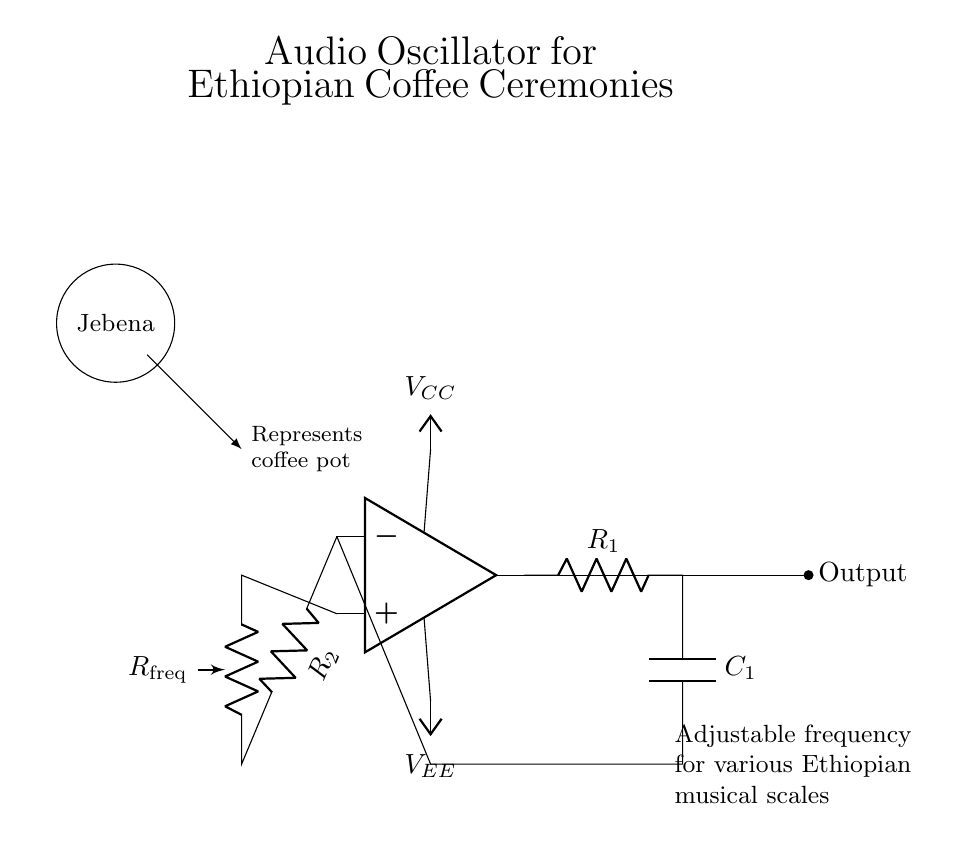What components are used in this oscillator? The components include an operational amplifier, resistors R1, R2, and Rfreq, and a capacitor C1. The operational amplifier is the main active component that provides the required gain for oscillation. The resistors and capacitor create a feedback network that determines the frequency of oscillation.
Answer: operational amplifier, resistors, capacitor What is the role of the capacitor in this circuit? The capacitor C1 is part of the feedback network and plays a critical role in determining the frequency of the generated audio signals. It works together with resistor R1 to set the timing characteristics of the oscillator, influencing how quickly the circuit can charge and discharge.
Answer: frequency determination What is the input voltage of the operational amplifier? The input voltage is denoted as Vcc for the positive and Vee for the negative supply. The circuit specifies power connections to the op-amp, indicating it operates with a dual power supply.
Answer: Vcc and Vee How does the frequency change in this circuit? The frequency can be adjusted by changing the resistance of Rfreq or the values of R1 and C1. An increase in the resistance or capacitance will lower the frequency, while a decrease will raise it. The circuit is designed to allow flexibility in tuning to accommodate different musical scales in Ethiopian music.
Answer: by adjusting Rfreq What does the symbol 'Jebena' represent in the circuit? The 'Jebena' symbol depicted above the circuit serves as a cultural reference, representing a traditional Ethiopian coffee pot used in ceremonies. It indicates the cultural significance of the audio oscillator in accompaniment to coffee ceremonies, integrating technology with cultural heritage.
Answer: coffee pot What is the output of the circuit? The output is an audio signal that is generated by the operational amplifier. This signal is expected to vary in frequency depending on the setup of the feedback network (resistors and capacitor), producing sounds suitable for traditional Ethiopian music.
Answer: audio signal 